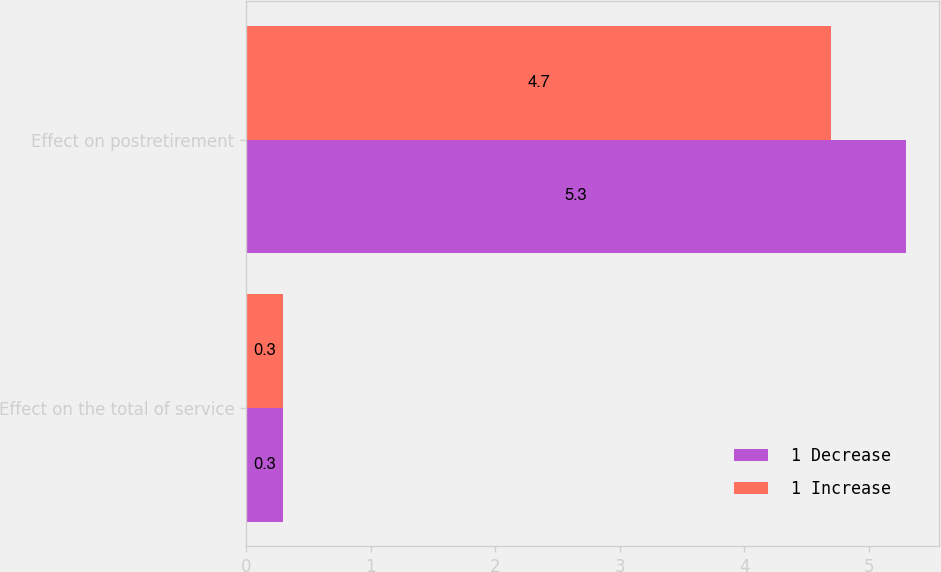Convert chart to OTSL. <chart><loc_0><loc_0><loc_500><loc_500><stacked_bar_chart><ecel><fcel>Effect on the total of service<fcel>Effect on postretirement<nl><fcel>1 Decrease<fcel>0.3<fcel>5.3<nl><fcel>1 Increase<fcel>0.3<fcel>4.7<nl></chart> 